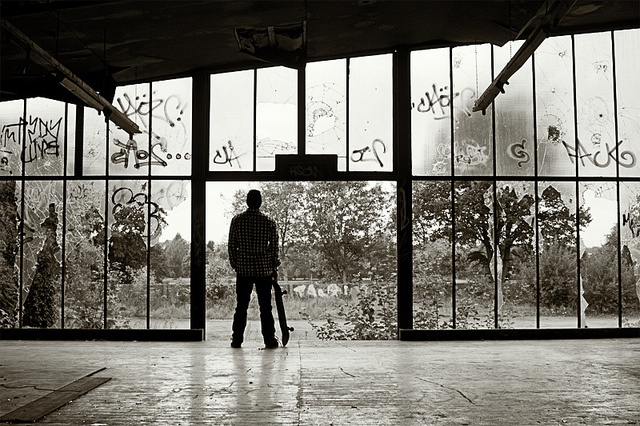Describe the objects in this image and their specific colors. I can see people in black, darkgray, gray, and lightgray tones and skateboard in black, gray, and darkgray tones in this image. 